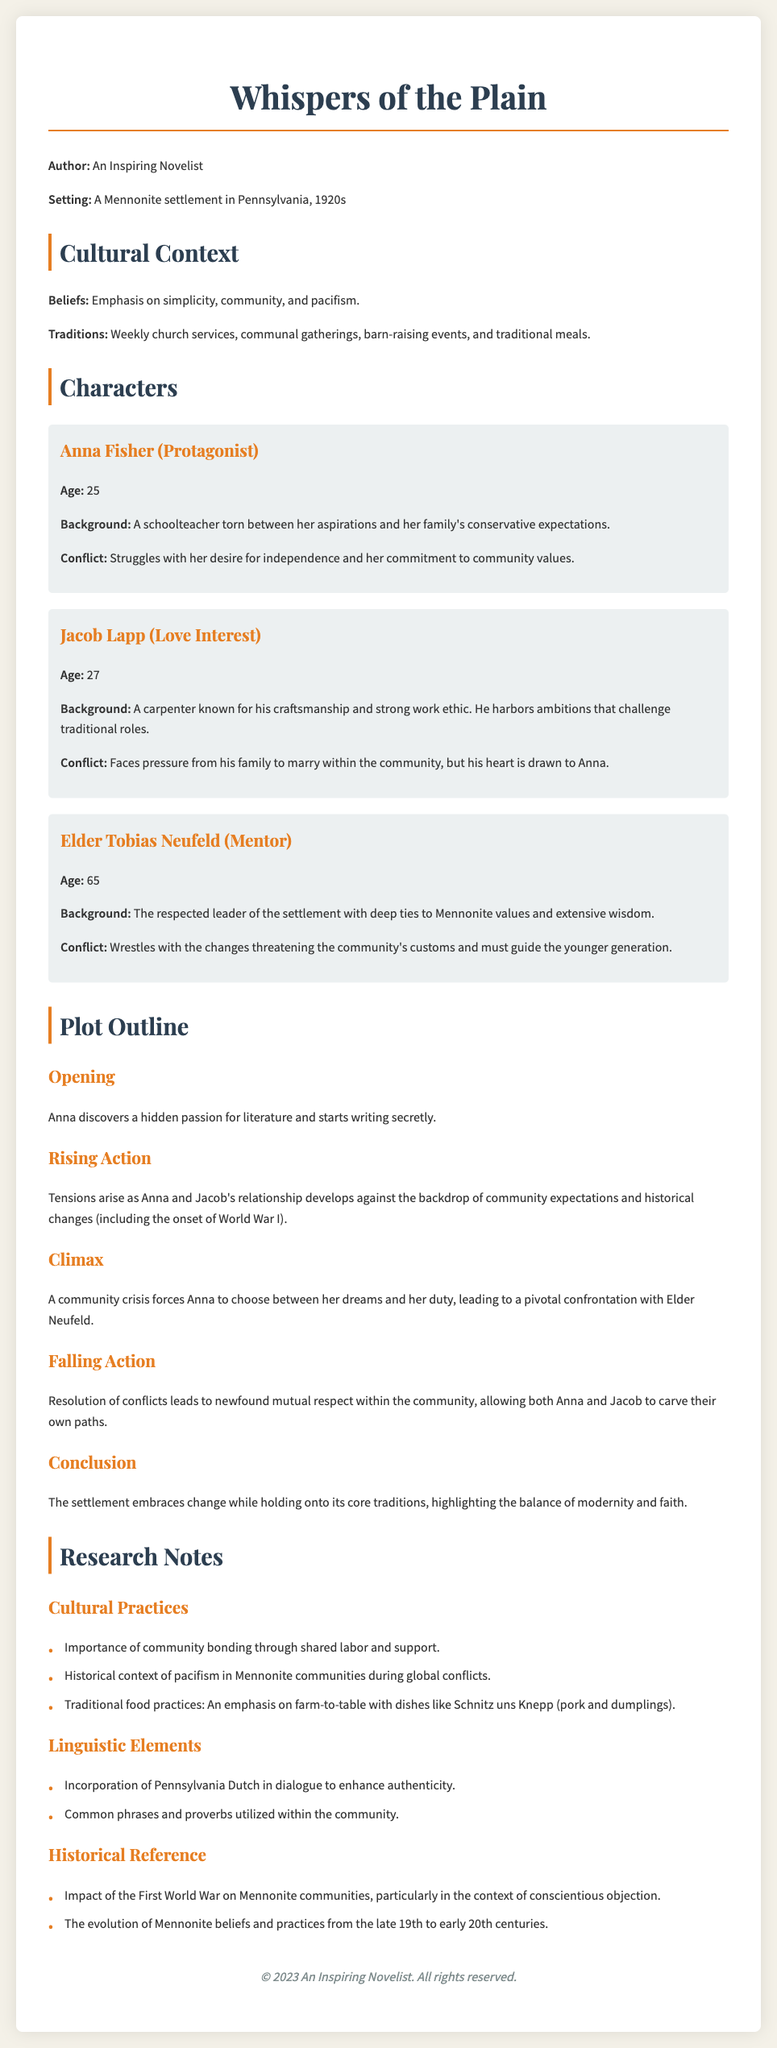What is the title of the novel? The title of the novel is prominently displayed at the top of the document.
Answer: Whispers of the Plain Who is the protagonist? The character sketch for the protagonist provides her name directly within the text.
Answer: Anna Fisher What year is the setting of the novel? The setting is indicated in the introduction section of the document.
Answer: 1920s What is Anna's age? Anna's age is explicitly mentioned in her character description.
Answer: 25 What is the primary conflict for Jacob? The conflict is detailed in the character description for Jacob Lapp, highlighting his pressures.
Answer: Marry within the community What does Elder Tobias Neufeld represent? This is summarized in his character description, recognizing his role in the community.
Answer: Mentor Which traditional dish is mentioned in the research notes? The research notes include specific details about traditional food practices.
Answer: Schnitz uns Knepp What significant historical event influences the story? The impact of this event is noted in the plot section, relating to community dynamics.
Answer: World War I 